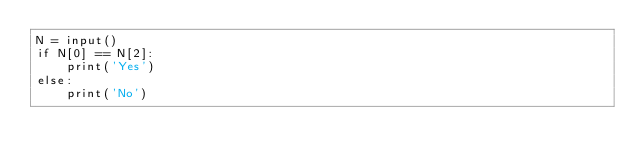<code> <loc_0><loc_0><loc_500><loc_500><_Python_>N = input()
if N[0] == N[2]:
    print('Yes')
else:
    print('No')</code> 